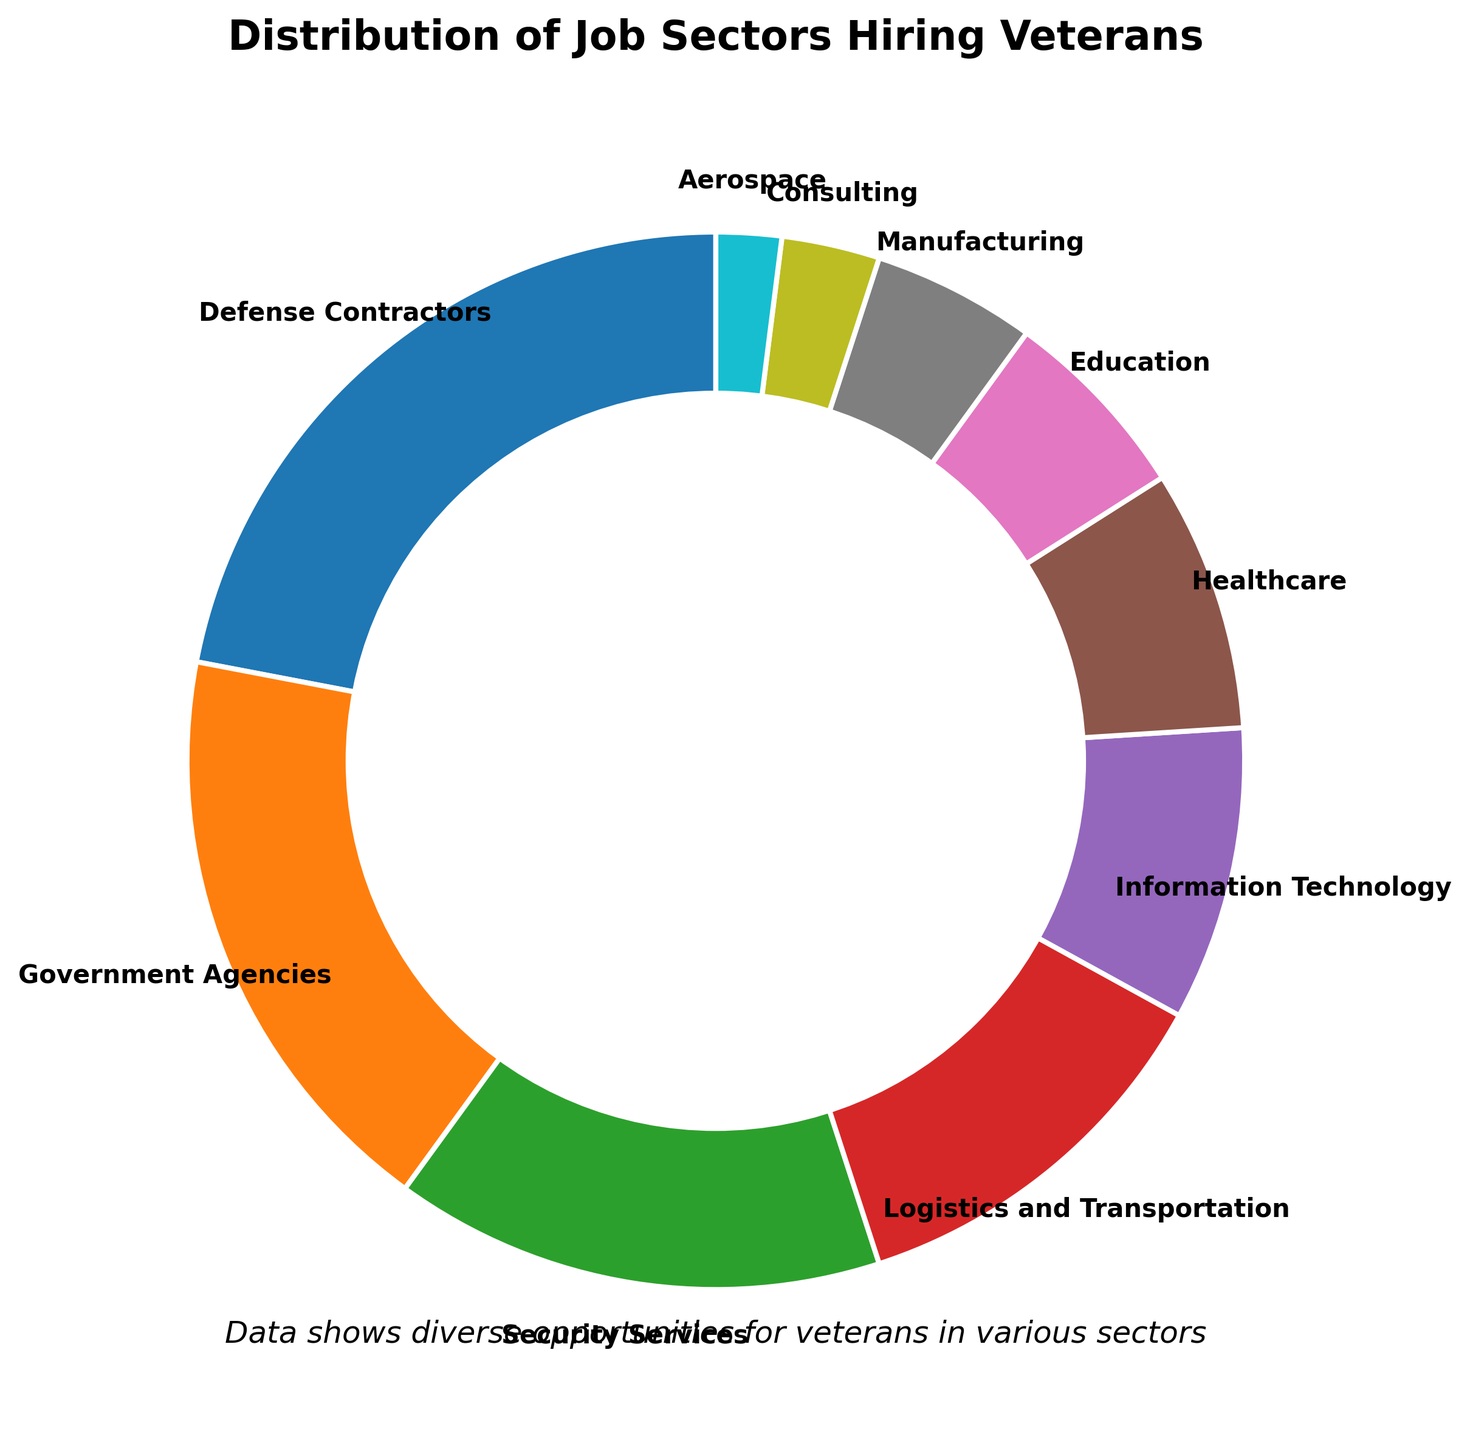What percentage of jobs are provided by the top two hiring sectors? First, identify the top two sectors, which are Defense Contractors at 22% and Government Agencies at 18%. Then sum these percentages: 22 + 18 = 40.
Answer: 40% Which sector provides more jobs, Information Technology or Healthcare? Compare the percentages: Information Technology provides 9% and Healthcare provides 8%. Since 9 is greater than 8, Information Technology provides more jobs.
Answer: Information Technology Are there more job opportunities in Manufacturing or Aerospace? Compare the percentages: Manufacturing provides 5% and Aerospace provides 2%. Since 5 is greater than 2, Manufacturing has more job opportunities.
Answer: Manufacturing What is the difference in job opportunities between Logistics and Transportation and Education sectors? Subtract the percentage of Education from Logistics and Transportation: 12 - 6 = 6.
Answer: 6% If you combine the roles in Security Services and Government Agencies, how does their total compare to Defense Contractors? Sum the percentages of Security Services and Government Agencies: 15 + 18 = 33. Compare this to Defense Contractors' 22%. Since 33 is greater than 22, the combined total is higher.
Answer: Combined is higher Which sector is represented by the slice closest to a 10% in size? Look at the chart and identify the sector with a percentage close to 10%, which is Information Technology at 9%.
Answer: Information Technology How many sectors provide less than 10% of job opportunities? Count the sectors with percentages less than 10%: Information Technology (9%), Healthcare (8%), Education (6%), Manufacturing (5%), Consulting (3%), and Aerospace (2%). There are 6 such sectors.
Answer: 6 What are the combined job opportunities in the sectors that are not in the top three? First, identify the top three sectors: Defense Contractors (22%), Government Agencies (18%), and Security Services (15%). Sum these: 22 + 18 + 15 = 55. Subtract this from 100% to get the combined percentage of the remaining sectors: 100 - 55 = 45.
Answer: 45% Which sector uses a red-colored slice? By referring to visual attributes and typical pie chart coloring conventions, red is often used for a prominent or high-percentage sector. Here, Security Services has a red slice at 15%.
Answer: Security Services What is the ratio of job opportunities between the Logistics and Transportation sectors and the Consulting sector? Divide the percentage of Logistics and Transportation by that of Consulting: 12 / 3 = 4.
Answer: 4:1 